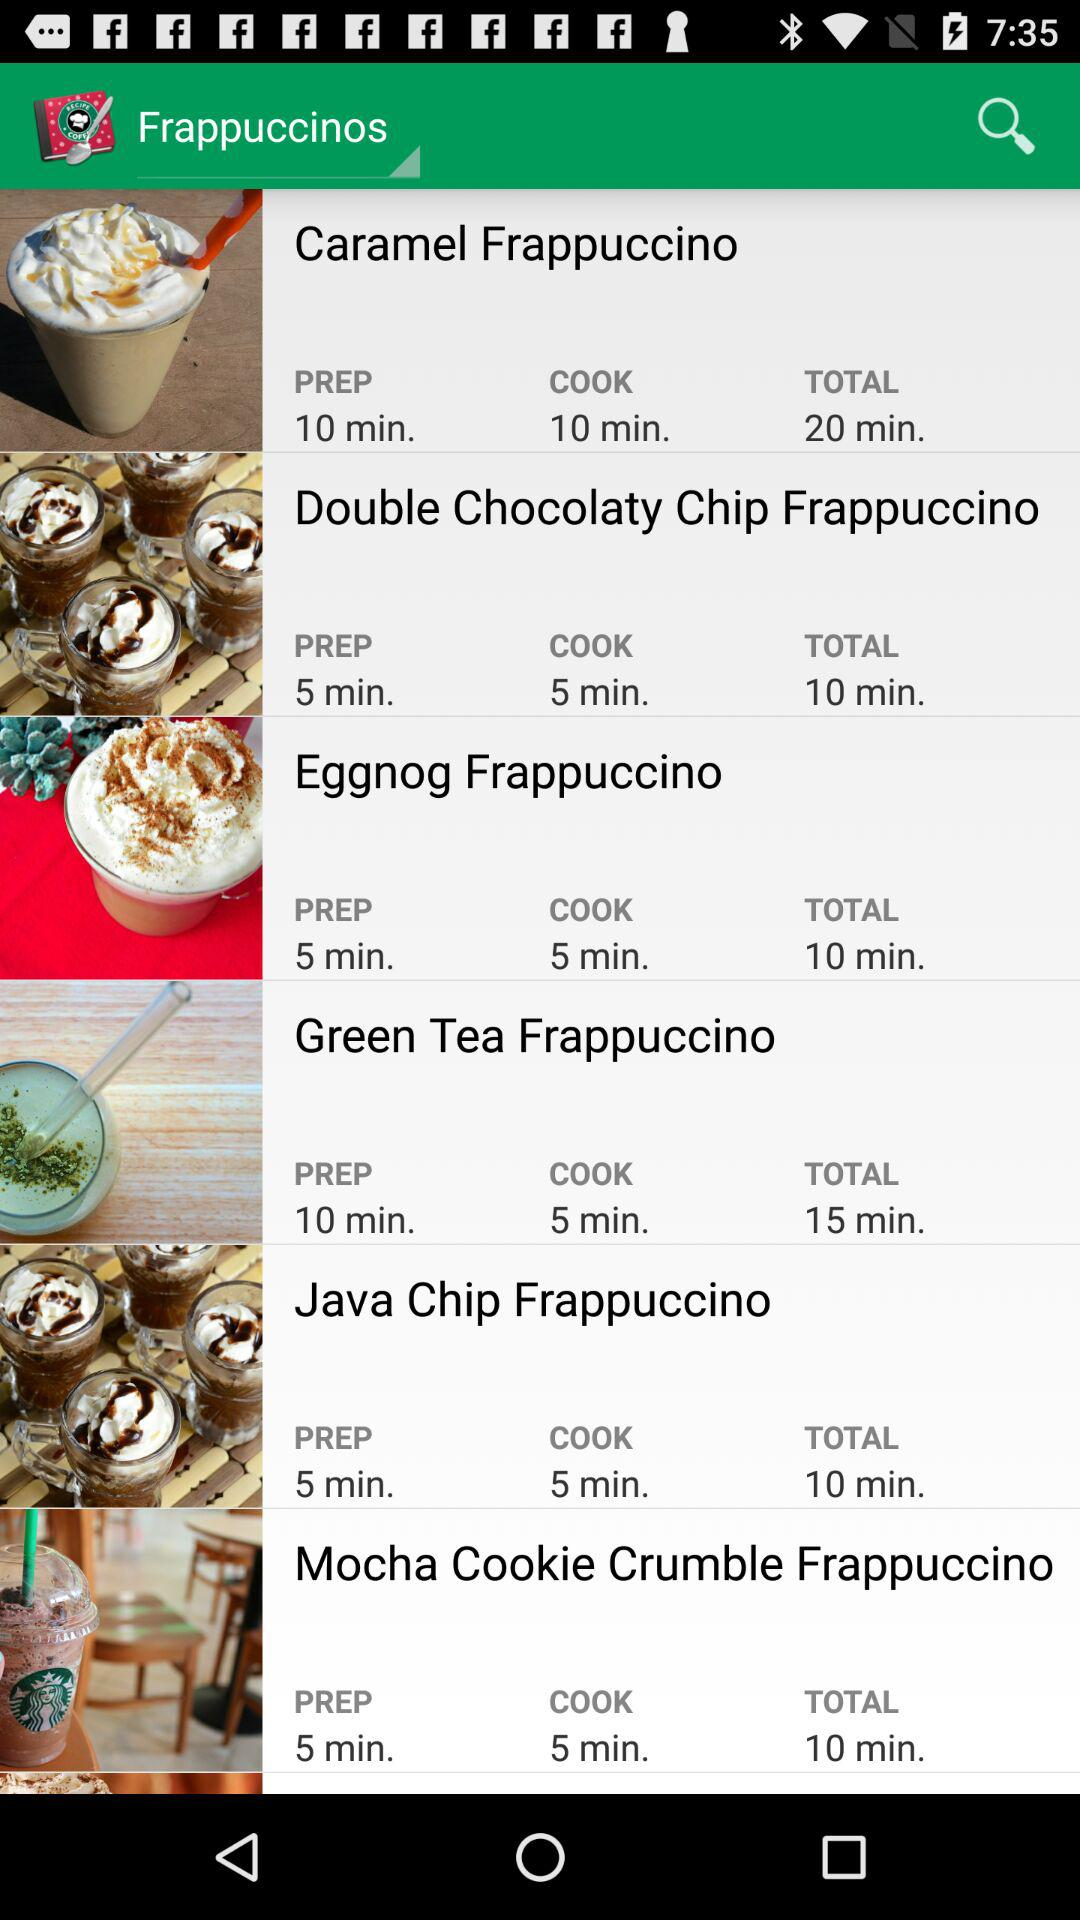What is the total time required to make "Java Chip Frappuccino"? The total time required to make "Java Chip Frappuccino" is 10 minutes. 